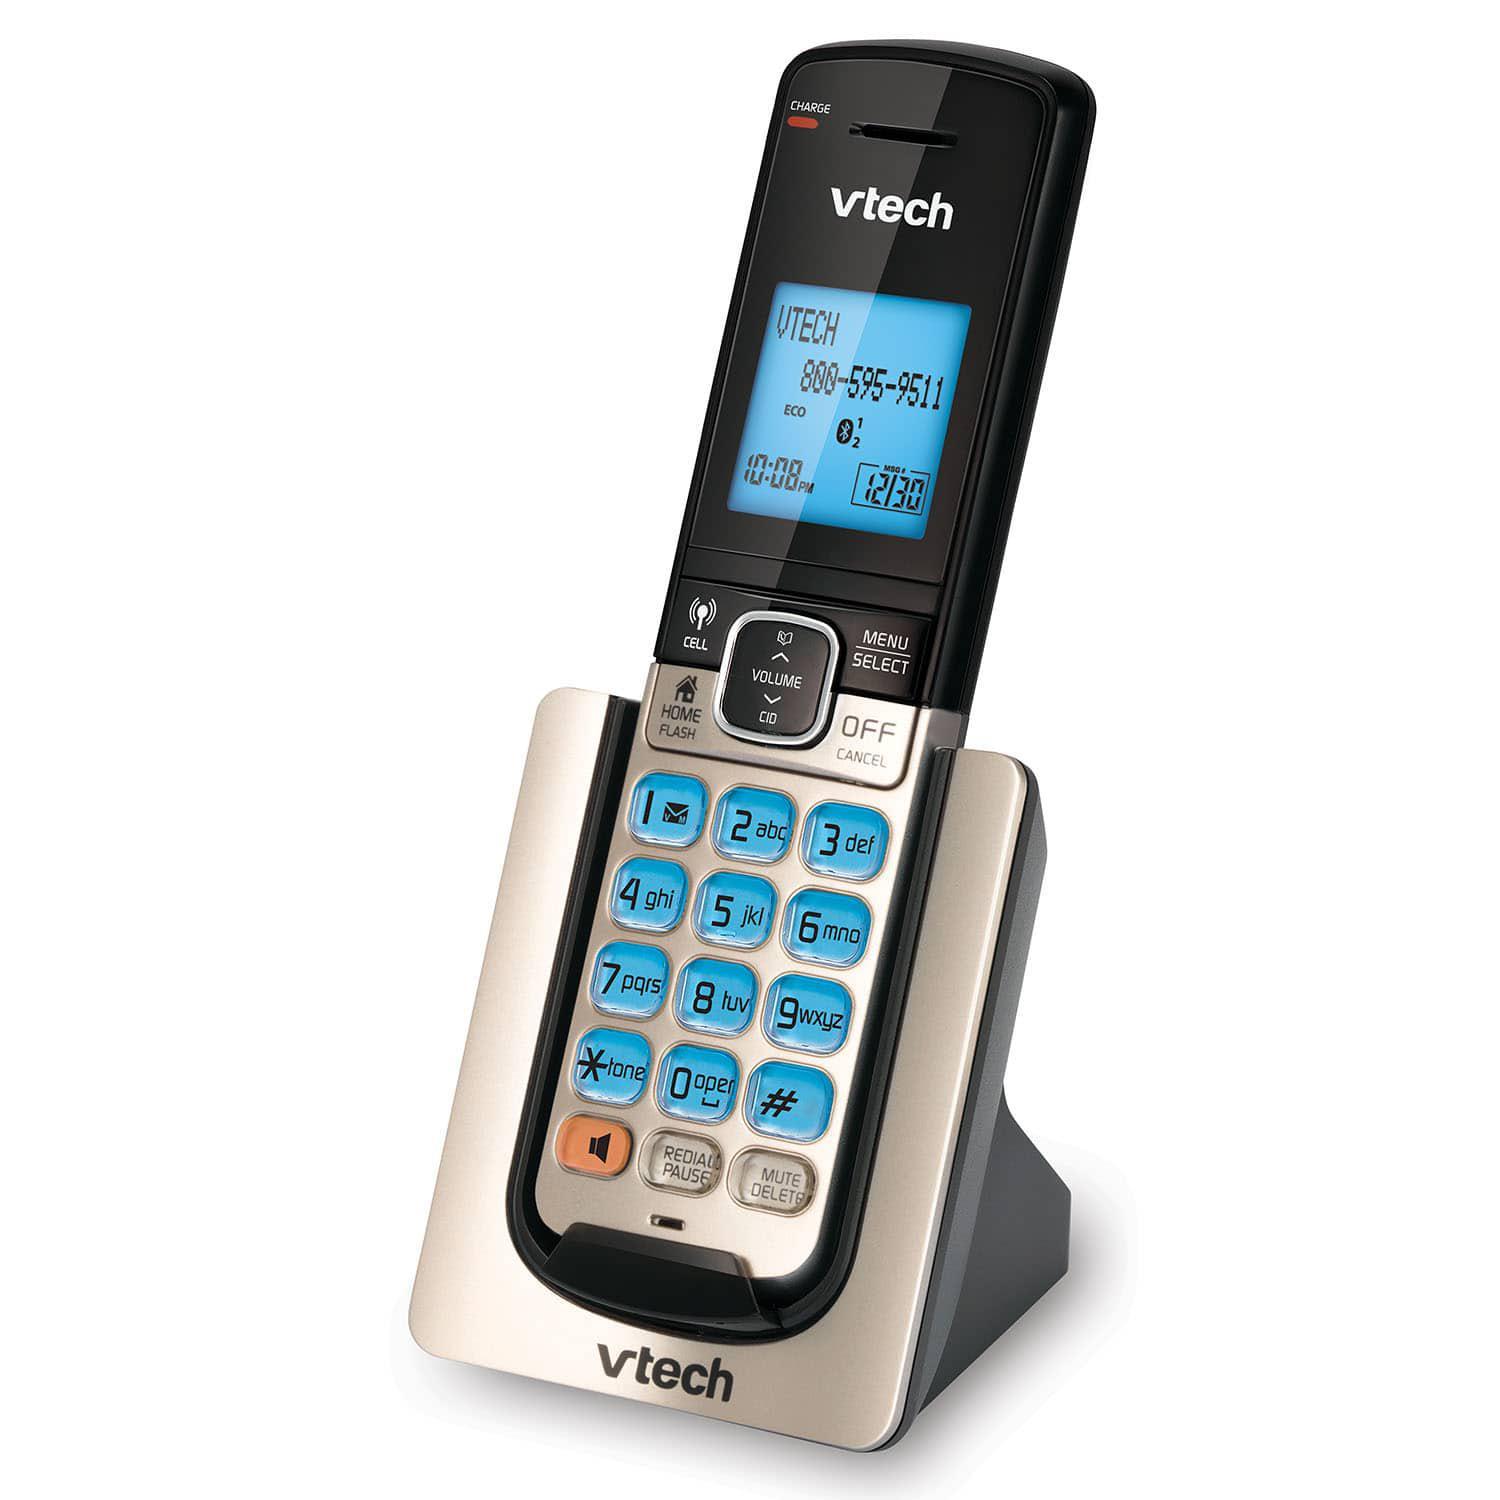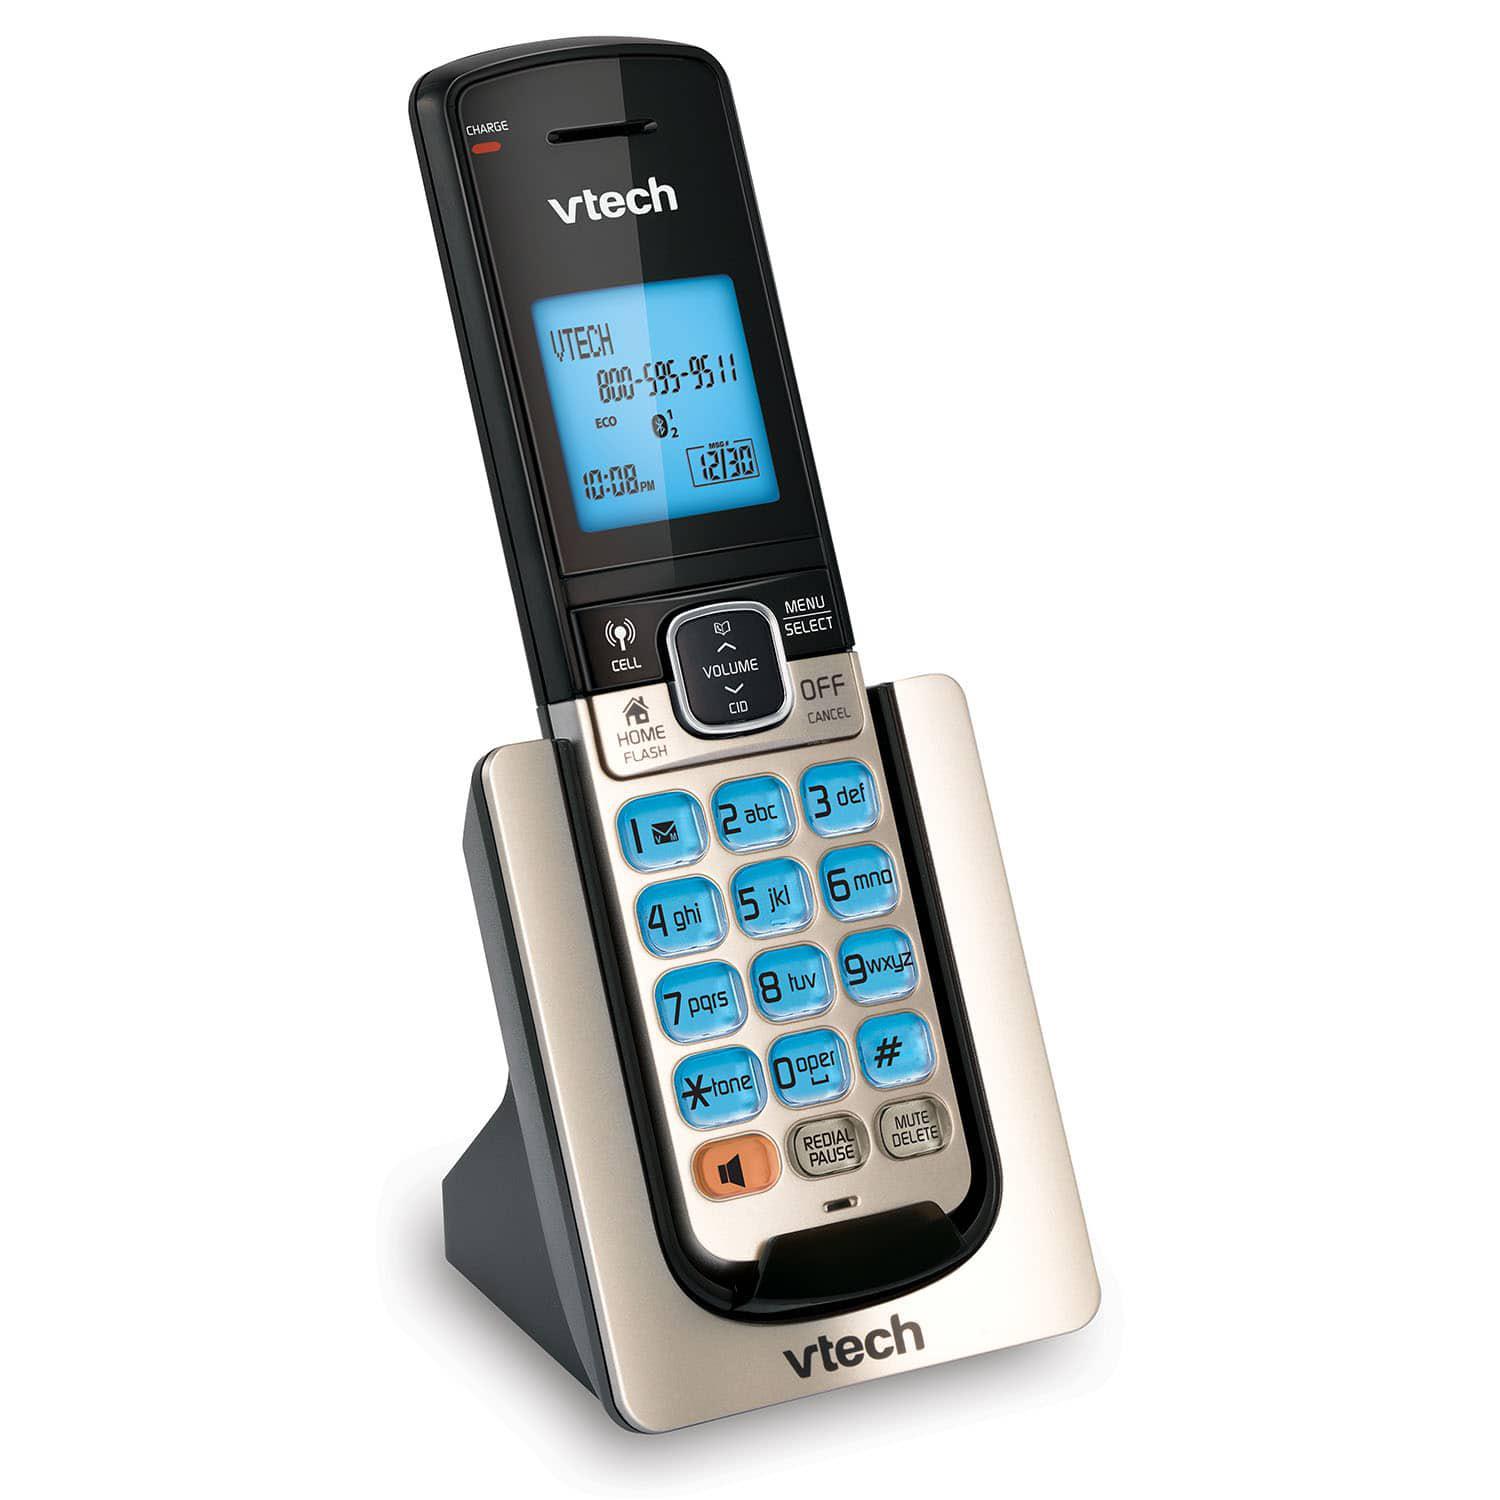The first image is the image on the left, the second image is the image on the right. Given the left and right images, does the statement "There are less than 4 phones." hold true? Answer yes or no. Yes. The first image is the image on the left, the second image is the image on the right. Assess this claim about the two images: "The combined images include two handsets that rest in silver stands and have a bright blue square screen on black.". Correct or not? Answer yes or no. Yes. 